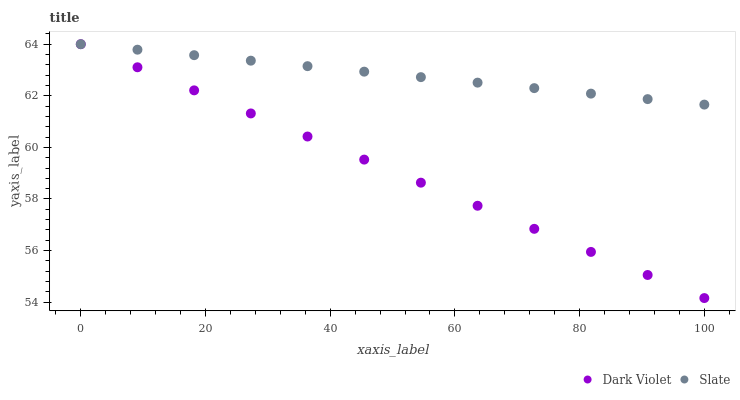Does Dark Violet have the minimum area under the curve?
Answer yes or no. Yes. Does Slate have the maximum area under the curve?
Answer yes or no. Yes. Does Dark Violet have the maximum area under the curve?
Answer yes or no. No. Is Slate the smoothest?
Answer yes or no. Yes. Is Dark Violet the roughest?
Answer yes or no. Yes. Is Dark Violet the smoothest?
Answer yes or no. No. Does Dark Violet have the lowest value?
Answer yes or no. Yes. Does Dark Violet have the highest value?
Answer yes or no. Yes. Does Dark Violet intersect Slate?
Answer yes or no. Yes. Is Dark Violet less than Slate?
Answer yes or no. No. Is Dark Violet greater than Slate?
Answer yes or no. No. 